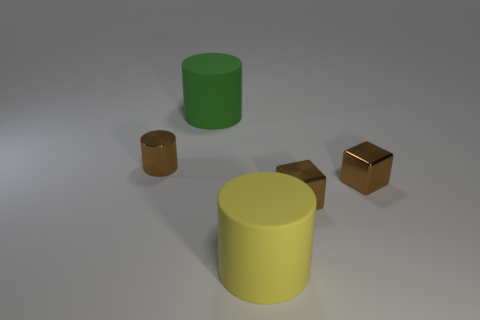What number of other objects are there of the same color as the tiny metal cylinder?
Provide a short and direct response. 2. How many objects are either yellow things or brown shiny cylinders?
Keep it short and to the point. 2. What number of objects are either tiny gray spheres or large cylinders to the right of the big green cylinder?
Offer a very short reply. 1. Are the brown cylinder and the green cylinder made of the same material?
Make the answer very short. No. How many other things are there of the same material as the big green cylinder?
Provide a short and direct response. 1. Is the number of red rubber objects greater than the number of small brown metal objects?
Ensure brevity in your answer.  No. There is a brown metallic thing on the left side of the big green thing; does it have the same shape as the big yellow thing?
Give a very brief answer. Yes. Are there fewer big rubber cylinders than tiny gray metal objects?
Give a very brief answer. No. There is a thing that is the same size as the yellow cylinder; what is it made of?
Provide a short and direct response. Rubber. Is the color of the tiny cylinder the same as the large matte thing left of the yellow cylinder?
Provide a short and direct response. No. 